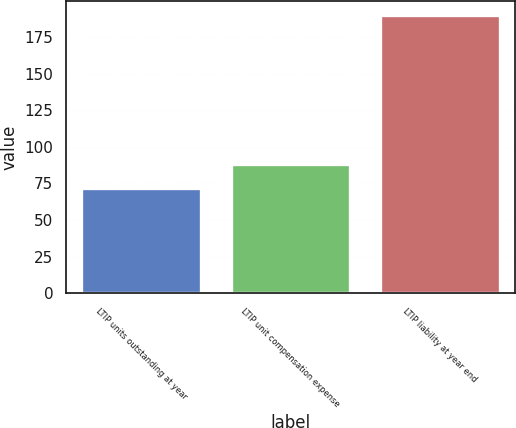Convert chart. <chart><loc_0><loc_0><loc_500><loc_500><bar_chart><fcel>LTIP units outstanding at year<fcel>LTIP unit compensation expense<fcel>LTIP liability at year end<nl><fcel>72<fcel>88<fcel>190<nl></chart> 